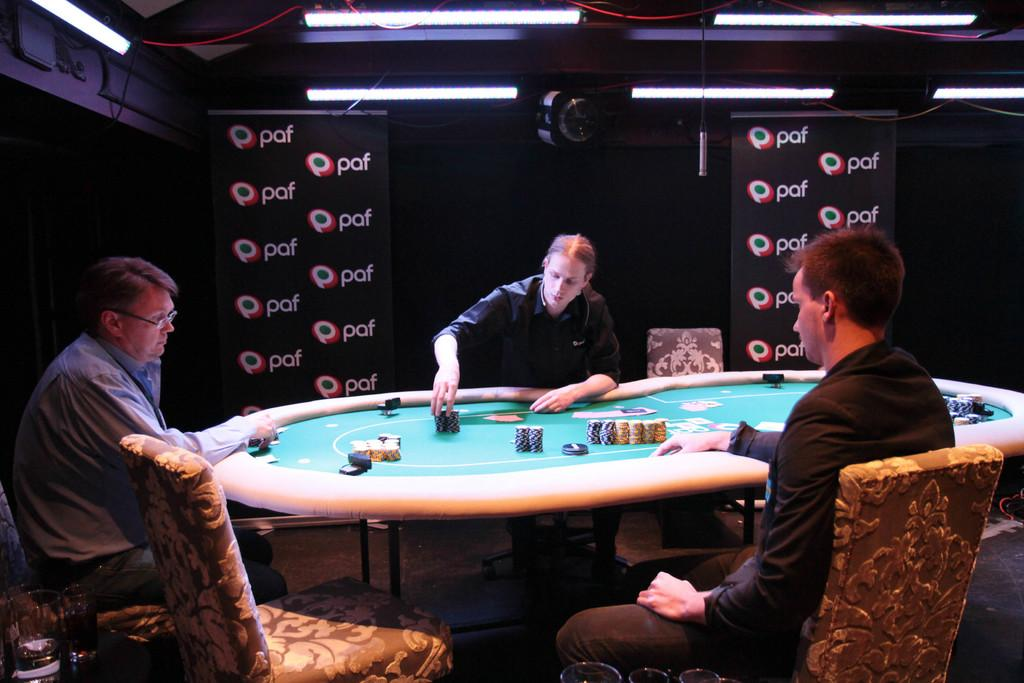What object is the main focus of the image? There is a camera in the image. How many people are present in the image? There are three people in the image. What are the people doing in the image? The people are sitting on chairs. How many lizards can be seen crawling on the camera in the image? There are no lizards present in the image; it only features a camera and three people sitting on chairs. What word is written on the camera in the image? There is no word written on the camera in the image. 